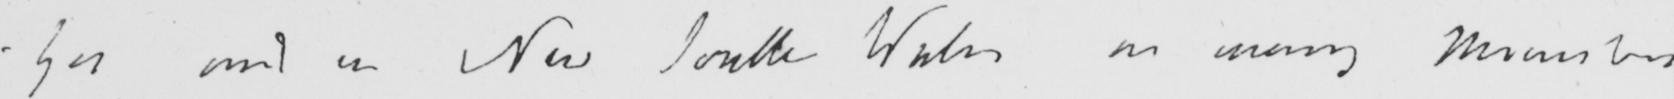Please provide the text content of this handwritten line. - yes and in New South Wales as many Ministers 